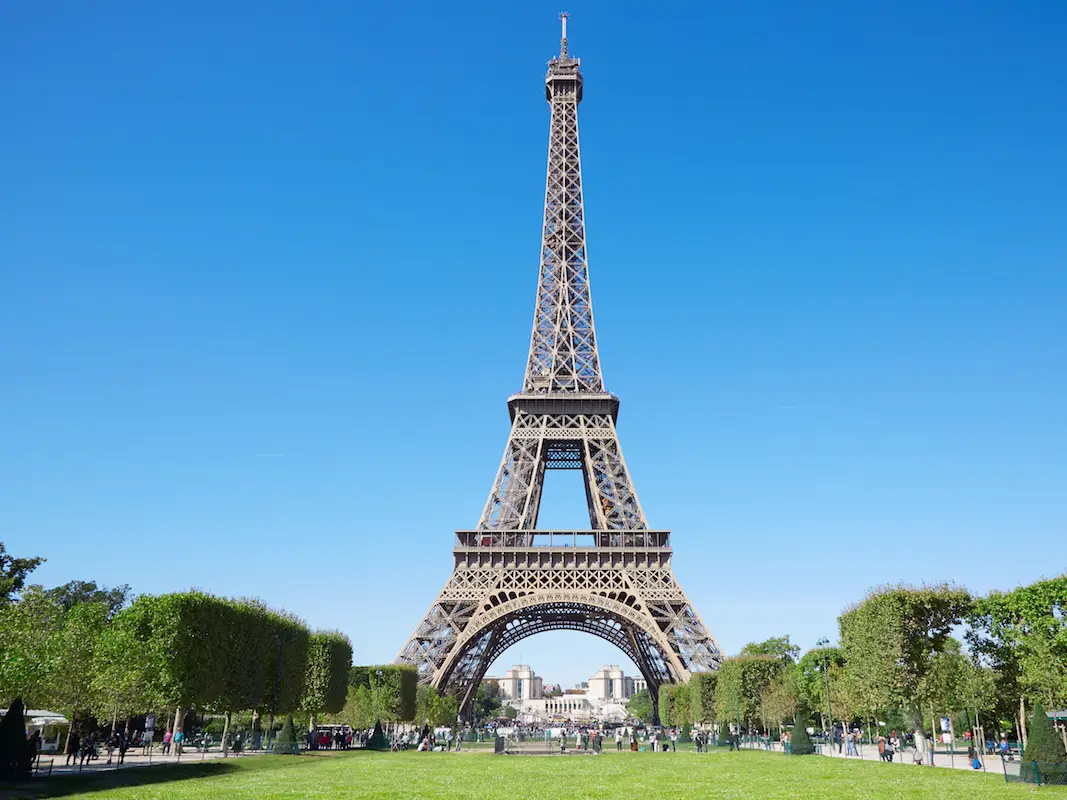How do people interact with this space on a typical day? On a typical day, the area around the Eiffel Tower is bustling with activity. Visitors often picnic on the Champ de Mars, the large public greenspace in front of the tower. Street performers, artists, and vendors add to the lively atmosphere, offering entertainment and souvenirs. Tourists and locals alike stroll or relax in the gardens, take photographs, and enjoy the tower's impressive architecture up close. It's a place where people come to marvel, relax, and connect. 